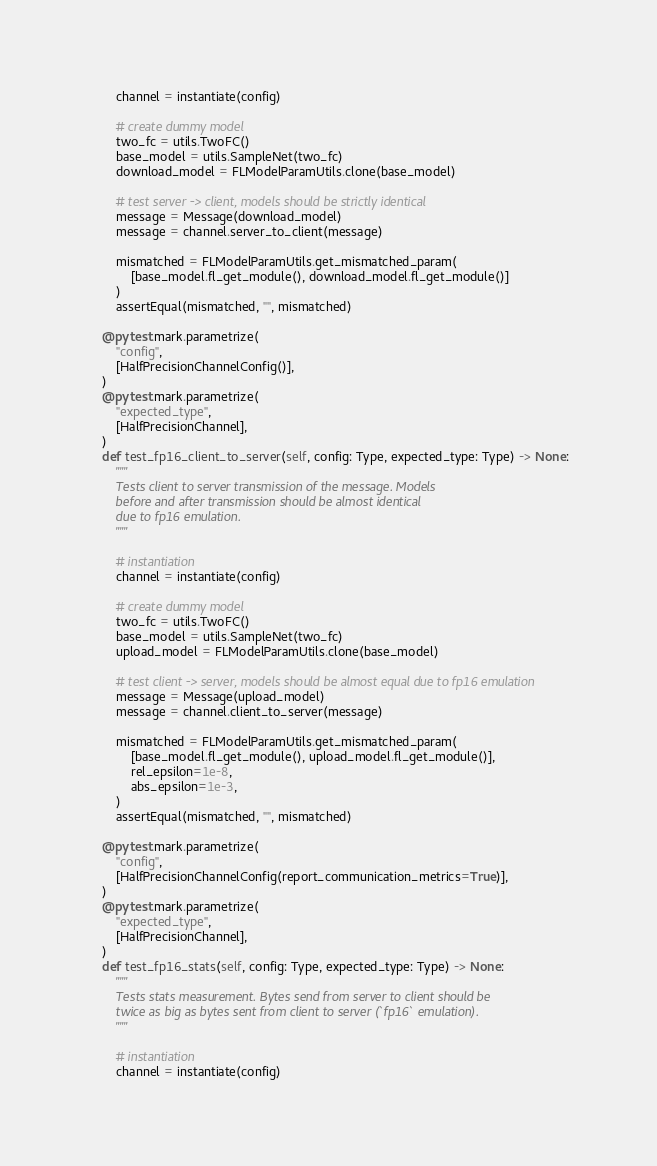<code> <loc_0><loc_0><loc_500><loc_500><_Python_>        channel = instantiate(config)

        # create dummy model
        two_fc = utils.TwoFC()
        base_model = utils.SampleNet(two_fc)
        download_model = FLModelParamUtils.clone(base_model)

        # test server -> client, models should be strictly identical
        message = Message(download_model)
        message = channel.server_to_client(message)

        mismatched = FLModelParamUtils.get_mismatched_param(
            [base_model.fl_get_module(), download_model.fl_get_module()]
        )
        assertEqual(mismatched, "", mismatched)

    @pytest.mark.parametrize(
        "config",
        [HalfPrecisionChannelConfig()],
    )
    @pytest.mark.parametrize(
        "expected_type",
        [HalfPrecisionChannel],
    )
    def test_fp16_client_to_server(self, config: Type, expected_type: Type) -> None:
        """
        Tests client to server transmission of the message. Models
        before and after transmission should be almost identical
        due to fp16 emulation.
        """

        # instantiation
        channel = instantiate(config)

        # create dummy model
        two_fc = utils.TwoFC()
        base_model = utils.SampleNet(two_fc)
        upload_model = FLModelParamUtils.clone(base_model)

        # test client -> server, models should be almost equal due to fp16 emulation
        message = Message(upload_model)
        message = channel.client_to_server(message)

        mismatched = FLModelParamUtils.get_mismatched_param(
            [base_model.fl_get_module(), upload_model.fl_get_module()],
            rel_epsilon=1e-8,
            abs_epsilon=1e-3,
        )
        assertEqual(mismatched, "", mismatched)

    @pytest.mark.parametrize(
        "config",
        [HalfPrecisionChannelConfig(report_communication_metrics=True)],
    )
    @pytest.mark.parametrize(
        "expected_type",
        [HalfPrecisionChannel],
    )
    def test_fp16_stats(self, config: Type, expected_type: Type) -> None:
        """
        Tests stats measurement. Bytes send from server to client should be
        twice as big as bytes sent from client to server (`fp16` emulation).
        """

        # instantiation
        channel = instantiate(config)</code> 